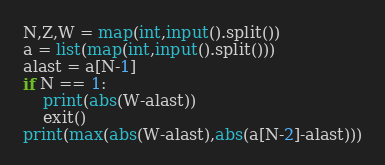<code> <loc_0><loc_0><loc_500><loc_500><_Python_>N,Z,W = map(int,input().split())
a = list(map(int,input().split())) 
alast = a[N-1]
if N == 1:
    print(abs(W-alast))
    exit()
print(max(abs(W-alast),abs(a[N-2]-alast)))</code> 